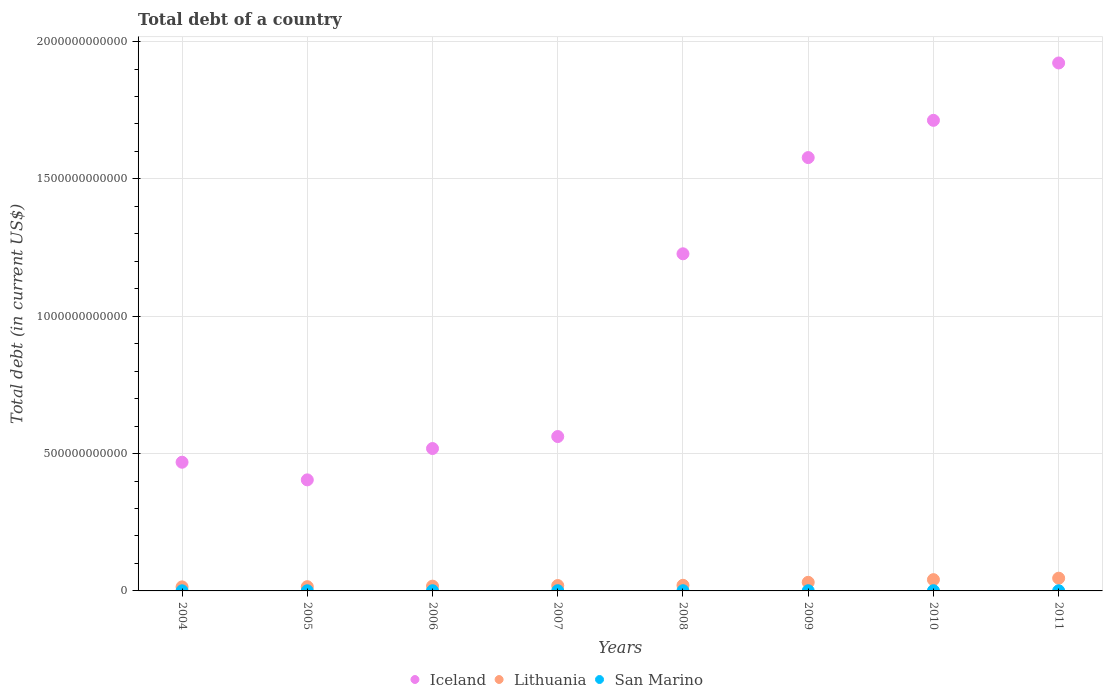Is the number of dotlines equal to the number of legend labels?
Provide a succinct answer. Yes. What is the debt in Lithuania in 2006?
Your response must be concise. 1.74e+1. Across all years, what is the maximum debt in Lithuania?
Give a very brief answer. 4.63e+1. Across all years, what is the minimum debt in San Marino?
Your response must be concise. 4.40e+08. In which year was the debt in Lithuania maximum?
Provide a succinct answer. 2011. In which year was the debt in Iceland minimum?
Keep it short and to the point. 2005. What is the total debt in San Marino in the graph?
Make the answer very short. 5.31e+09. What is the difference between the debt in Iceland in 2004 and that in 2006?
Provide a short and direct response. -4.99e+1. What is the difference between the debt in Iceland in 2010 and the debt in Lithuania in 2009?
Offer a very short reply. 1.68e+12. What is the average debt in Iceland per year?
Offer a terse response. 1.05e+12. In the year 2010, what is the difference between the debt in San Marino and debt in Lithuania?
Make the answer very short. -4.02e+1. What is the ratio of the debt in Iceland in 2008 to that in 2011?
Offer a terse response. 0.64. What is the difference between the highest and the second highest debt in San Marino?
Your answer should be very brief. 1.42e+07. What is the difference between the highest and the lowest debt in San Marino?
Make the answer very short. 3.40e+08. Is the sum of the debt in San Marino in 2005 and 2011 greater than the maximum debt in Lithuania across all years?
Your answer should be compact. No. Does the debt in San Marino monotonically increase over the years?
Your answer should be compact. No. How many dotlines are there?
Keep it short and to the point. 3. How many years are there in the graph?
Provide a succinct answer. 8. What is the difference between two consecutive major ticks on the Y-axis?
Your response must be concise. 5.00e+11. Are the values on the major ticks of Y-axis written in scientific E-notation?
Provide a succinct answer. No. Does the graph contain grids?
Make the answer very short. Yes. What is the title of the graph?
Make the answer very short. Total debt of a country. Does "European Union" appear as one of the legend labels in the graph?
Offer a very short reply. No. What is the label or title of the Y-axis?
Your response must be concise. Total debt (in current US$). What is the Total debt (in current US$) in Iceland in 2004?
Ensure brevity in your answer.  4.69e+11. What is the Total debt (in current US$) of Lithuania in 2004?
Make the answer very short. 1.47e+1. What is the Total debt (in current US$) in San Marino in 2004?
Keep it short and to the point. 4.40e+08. What is the Total debt (in current US$) of Iceland in 2005?
Offer a very short reply. 4.04e+11. What is the Total debt (in current US$) in Lithuania in 2005?
Make the answer very short. 1.54e+1. What is the Total debt (in current US$) of San Marino in 2005?
Your answer should be very brief. 5.65e+08. What is the Total debt (in current US$) in Iceland in 2006?
Your answer should be very brief. 5.18e+11. What is the Total debt (in current US$) in Lithuania in 2006?
Keep it short and to the point. 1.74e+1. What is the Total debt (in current US$) of San Marino in 2006?
Your answer should be very brief. 7.27e+08. What is the Total debt (in current US$) in Iceland in 2007?
Make the answer very short. 5.62e+11. What is the Total debt (in current US$) in Lithuania in 2007?
Give a very brief answer. 1.96e+1. What is the Total debt (in current US$) in San Marino in 2007?
Keep it short and to the point. 7.58e+08. What is the Total debt (in current US$) of Iceland in 2008?
Offer a very short reply. 1.23e+12. What is the Total debt (in current US$) in Lithuania in 2008?
Your answer should be compact. 2.05e+1. What is the Total debt (in current US$) in San Marino in 2008?
Offer a terse response. 7.66e+08. What is the Total debt (in current US$) in Iceland in 2009?
Offer a very short reply. 1.58e+12. What is the Total debt (in current US$) in Lithuania in 2009?
Offer a terse response. 3.13e+1. What is the Total debt (in current US$) in San Marino in 2009?
Your response must be concise. 6.90e+08. What is the Total debt (in current US$) of Iceland in 2010?
Ensure brevity in your answer.  1.71e+12. What is the Total debt (in current US$) in Lithuania in 2010?
Make the answer very short. 4.10e+1. What is the Total debt (in current US$) in San Marino in 2010?
Keep it short and to the point. 7.80e+08. What is the Total debt (in current US$) in Iceland in 2011?
Offer a very short reply. 1.92e+12. What is the Total debt (in current US$) of Lithuania in 2011?
Provide a short and direct response. 4.63e+1. What is the Total debt (in current US$) of San Marino in 2011?
Offer a very short reply. 5.84e+08. Across all years, what is the maximum Total debt (in current US$) of Iceland?
Your response must be concise. 1.92e+12. Across all years, what is the maximum Total debt (in current US$) in Lithuania?
Your response must be concise. 4.63e+1. Across all years, what is the maximum Total debt (in current US$) in San Marino?
Make the answer very short. 7.80e+08. Across all years, what is the minimum Total debt (in current US$) of Iceland?
Your answer should be compact. 4.04e+11. Across all years, what is the minimum Total debt (in current US$) of Lithuania?
Ensure brevity in your answer.  1.47e+1. Across all years, what is the minimum Total debt (in current US$) in San Marino?
Your response must be concise. 4.40e+08. What is the total Total debt (in current US$) in Iceland in the graph?
Ensure brevity in your answer.  8.39e+12. What is the total Total debt (in current US$) of Lithuania in the graph?
Your answer should be compact. 2.06e+11. What is the total Total debt (in current US$) of San Marino in the graph?
Make the answer very short. 5.31e+09. What is the difference between the Total debt (in current US$) in Iceland in 2004 and that in 2005?
Your answer should be compact. 6.42e+1. What is the difference between the Total debt (in current US$) of Lithuania in 2004 and that in 2005?
Your answer should be very brief. -7.45e+08. What is the difference between the Total debt (in current US$) in San Marino in 2004 and that in 2005?
Your answer should be compact. -1.25e+08. What is the difference between the Total debt (in current US$) of Iceland in 2004 and that in 2006?
Your answer should be compact. -4.99e+1. What is the difference between the Total debt (in current US$) in Lithuania in 2004 and that in 2006?
Offer a very short reply. -2.73e+09. What is the difference between the Total debt (in current US$) of San Marino in 2004 and that in 2006?
Your answer should be compact. -2.86e+08. What is the difference between the Total debt (in current US$) of Iceland in 2004 and that in 2007?
Offer a very short reply. -9.35e+1. What is the difference between the Total debt (in current US$) in Lithuania in 2004 and that in 2007?
Keep it short and to the point. -4.96e+09. What is the difference between the Total debt (in current US$) in San Marino in 2004 and that in 2007?
Give a very brief answer. -3.18e+08. What is the difference between the Total debt (in current US$) of Iceland in 2004 and that in 2008?
Provide a succinct answer. -7.59e+11. What is the difference between the Total debt (in current US$) in Lithuania in 2004 and that in 2008?
Keep it short and to the point. -5.81e+09. What is the difference between the Total debt (in current US$) in San Marino in 2004 and that in 2008?
Offer a terse response. -3.26e+08. What is the difference between the Total debt (in current US$) in Iceland in 2004 and that in 2009?
Your answer should be very brief. -1.11e+12. What is the difference between the Total debt (in current US$) in Lithuania in 2004 and that in 2009?
Make the answer very short. -1.66e+1. What is the difference between the Total debt (in current US$) of San Marino in 2004 and that in 2009?
Provide a succinct answer. -2.50e+08. What is the difference between the Total debt (in current US$) of Iceland in 2004 and that in 2010?
Offer a very short reply. -1.24e+12. What is the difference between the Total debt (in current US$) of Lithuania in 2004 and that in 2010?
Your answer should be very brief. -2.64e+1. What is the difference between the Total debt (in current US$) in San Marino in 2004 and that in 2010?
Provide a short and direct response. -3.40e+08. What is the difference between the Total debt (in current US$) in Iceland in 2004 and that in 2011?
Provide a short and direct response. -1.45e+12. What is the difference between the Total debt (in current US$) in Lithuania in 2004 and that in 2011?
Give a very brief answer. -3.17e+1. What is the difference between the Total debt (in current US$) of San Marino in 2004 and that in 2011?
Make the answer very short. -1.44e+08. What is the difference between the Total debt (in current US$) in Iceland in 2005 and that in 2006?
Your answer should be compact. -1.14e+11. What is the difference between the Total debt (in current US$) of Lithuania in 2005 and that in 2006?
Your answer should be compact. -1.99e+09. What is the difference between the Total debt (in current US$) in San Marino in 2005 and that in 2006?
Give a very brief answer. -1.62e+08. What is the difference between the Total debt (in current US$) of Iceland in 2005 and that in 2007?
Your response must be concise. -1.58e+11. What is the difference between the Total debt (in current US$) in Lithuania in 2005 and that in 2007?
Provide a succinct answer. -4.22e+09. What is the difference between the Total debt (in current US$) in San Marino in 2005 and that in 2007?
Provide a short and direct response. -1.93e+08. What is the difference between the Total debt (in current US$) of Iceland in 2005 and that in 2008?
Offer a terse response. -8.23e+11. What is the difference between the Total debt (in current US$) in Lithuania in 2005 and that in 2008?
Your answer should be compact. -5.07e+09. What is the difference between the Total debt (in current US$) of San Marino in 2005 and that in 2008?
Provide a succinct answer. -2.01e+08. What is the difference between the Total debt (in current US$) of Iceland in 2005 and that in 2009?
Give a very brief answer. -1.17e+12. What is the difference between the Total debt (in current US$) of Lithuania in 2005 and that in 2009?
Keep it short and to the point. -1.59e+1. What is the difference between the Total debt (in current US$) in San Marino in 2005 and that in 2009?
Your answer should be very brief. -1.25e+08. What is the difference between the Total debt (in current US$) of Iceland in 2005 and that in 2010?
Give a very brief answer. -1.31e+12. What is the difference between the Total debt (in current US$) in Lithuania in 2005 and that in 2010?
Offer a very short reply. -2.56e+1. What is the difference between the Total debt (in current US$) of San Marino in 2005 and that in 2010?
Provide a succinct answer. -2.15e+08. What is the difference between the Total debt (in current US$) in Iceland in 2005 and that in 2011?
Keep it short and to the point. -1.52e+12. What is the difference between the Total debt (in current US$) of Lithuania in 2005 and that in 2011?
Your response must be concise. -3.09e+1. What is the difference between the Total debt (in current US$) in San Marino in 2005 and that in 2011?
Provide a succinct answer. -1.92e+07. What is the difference between the Total debt (in current US$) in Iceland in 2006 and that in 2007?
Provide a short and direct response. -4.37e+1. What is the difference between the Total debt (in current US$) of Lithuania in 2006 and that in 2007?
Ensure brevity in your answer.  -2.23e+09. What is the difference between the Total debt (in current US$) of San Marino in 2006 and that in 2007?
Your answer should be compact. -3.13e+07. What is the difference between the Total debt (in current US$) in Iceland in 2006 and that in 2008?
Your answer should be compact. -7.09e+11. What is the difference between the Total debt (in current US$) of Lithuania in 2006 and that in 2008?
Your response must be concise. -3.08e+09. What is the difference between the Total debt (in current US$) in San Marino in 2006 and that in 2008?
Give a very brief answer. -3.93e+07. What is the difference between the Total debt (in current US$) of Iceland in 2006 and that in 2009?
Give a very brief answer. -1.06e+12. What is the difference between the Total debt (in current US$) in Lithuania in 2006 and that in 2009?
Give a very brief answer. -1.39e+1. What is the difference between the Total debt (in current US$) in San Marino in 2006 and that in 2009?
Your response must be concise. 3.67e+07. What is the difference between the Total debt (in current US$) of Iceland in 2006 and that in 2010?
Your response must be concise. -1.19e+12. What is the difference between the Total debt (in current US$) in Lithuania in 2006 and that in 2010?
Your response must be concise. -2.36e+1. What is the difference between the Total debt (in current US$) in San Marino in 2006 and that in 2010?
Your answer should be compact. -5.35e+07. What is the difference between the Total debt (in current US$) in Iceland in 2006 and that in 2011?
Ensure brevity in your answer.  -1.40e+12. What is the difference between the Total debt (in current US$) in Lithuania in 2006 and that in 2011?
Ensure brevity in your answer.  -2.89e+1. What is the difference between the Total debt (in current US$) in San Marino in 2006 and that in 2011?
Provide a short and direct response. 1.42e+08. What is the difference between the Total debt (in current US$) in Iceland in 2007 and that in 2008?
Make the answer very short. -6.65e+11. What is the difference between the Total debt (in current US$) of Lithuania in 2007 and that in 2008?
Ensure brevity in your answer.  -8.50e+08. What is the difference between the Total debt (in current US$) of San Marino in 2007 and that in 2008?
Offer a terse response. -8.04e+06. What is the difference between the Total debt (in current US$) in Iceland in 2007 and that in 2009?
Provide a short and direct response. -1.02e+12. What is the difference between the Total debt (in current US$) in Lithuania in 2007 and that in 2009?
Your answer should be compact. -1.17e+1. What is the difference between the Total debt (in current US$) of San Marino in 2007 and that in 2009?
Offer a terse response. 6.80e+07. What is the difference between the Total debt (in current US$) in Iceland in 2007 and that in 2010?
Your answer should be very brief. -1.15e+12. What is the difference between the Total debt (in current US$) of Lithuania in 2007 and that in 2010?
Provide a succinct answer. -2.14e+1. What is the difference between the Total debt (in current US$) in San Marino in 2007 and that in 2010?
Your answer should be compact. -2.23e+07. What is the difference between the Total debt (in current US$) in Iceland in 2007 and that in 2011?
Provide a succinct answer. -1.36e+12. What is the difference between the Total debt (in current US$) of Lithuania in 2007 and that in 2011?
Your answer should be very brief. -2.67e+1. What is the difference between the Total debt (in current US$) in San Marino in 2007 and that in 2011?
Ensure brevity in your answer.  1.74e+08. What is the difference between the Total debt (in current US$) in Iceland in 2008 and that in 2009?
Keep it short and to the point. -3.50e+11. What is the difference between the Total debt (in current US$) of Lithuania in 2008 and that in 2009?
Offer a very short reply. -1.08e+1. What is the difference between the Total debt (in current US$) of San Marino in 2008 and that in 2009?
Your response must be concise. 7.60e+07. What is the difference between the Total debt (in current US$) in Iceland in 2008 and that in 2010?
Make the answer very short. -4.86e+11. What is the difference between the Total debt (in current US$) in Lithuania in 2008 and that in 2010?
Keep it short and to the point. -2.06e+1. What is the difference between the Total debt (in current US$) in San Marino in 2008 and that in 2010?
Give a very brief answer. -1.42e+07. What is the difference between the Total debt (in current US$) in Iceland in 2008 and that in 2011?
Give a very brief answer. -6.95e+11. What is the difference between the Total debt (in current US$) of Lithuania in 2008 and that in 2011?
Your answer should be very brief. -2.58e+1. What is the difference between the Total debt (in current US$) in San Marino in 2008 and that in 2011?
Your answer should be compact. 1.82e+08. What is the difference between the Total debt (in current US$) in Iceland in 2009 and that in 2010?
Give a very brief answer. -1.36e+11. What is the difference between the Total debt (in current US$) of Lithuania in 2009 and that in 2010?
Your response must be concise. -9.73e+09. What is the difference between the Total debt (in current US$) in San Marino in 2009 and that in 2010?
Ensure brevity in your answer.  -9.03e+07. What is the difference between the Total debt (in current US$) of Iceland in 2009 and that in 2011?
Provide a short and direct response. -3.44e+11. What is the difference between the Total debt (in current US$) in Lithuania in 2009 and that in 2011?
Offer a very short reply. -1.50e+1. What is the difference between the Total debt (in current US$) in San Marino in 2009 and that in 2011?
Offer a very short reply. 1.06e+08. What is the difference between the Total debt (in current US$) of Iceland in 2010 and that in 2011?
Give a very brief answer. -2.09e+11. What is the difference between the Total debt (in current US$) of Lithuania in 2010 and that in 2011?
Keep it short and to the point. -5.29e+09. What is the difference between the Total debt (in current US$) of San Marino in 2010 and that in 2011?
Provide a short and direct response. 1.96e+08. What is the difference between the Total debt (in current US$) in Iceland in 2004 and the Total debt (in current US$) in Lithuania in 2005?
Offer a very short reply. 4.53e+11. What is the difference between the Total debt (in current US$) in Iceland in 2004 and the Total debt (in current US$) in San Marino in 2005?
Your response must be concise. 4.68e+11. What is the difference between the Total debt (in current US$) in Lithuania in 2004 and the Total debt (in current US$) in San Marino in 2005?
Make the answer very short. 1.41e+1. What is the difference between the Total debt (in current US$) in Iceland in 2004 and the Total debt (in current US$) in Lithuania in 2006?
Your answer should be very brief. 4.51e+11. What is the difference between the Total debt (in current US$) in Iceland in 2004 and the Total debt (in current US$) in San Marino in 2006?
Offer a very short reply. 4.68e+11. What is the difference between the Total debt (in current US$) in Lithuania in 2004 and the Total debt (in current US$) in San Marino in 2006?
Your answer should be very brief. 1.39e+1. What is the difference between the Total debt (in current US$) in Iceland in 2004 and the Total debt (in current US$) in Lithuania in 2007?
Your answer should be compact. 4.49e+11. What is the difference between the Total debt (in current US$) in Iceland in 2004 and the Total debt (in current US$) in San Marino in 2007?
Keep it short and to the point. 4.68e+11. What is the difference between the Total debt (in current US$) of Lithuania in 2004 and the Total debt (in current US$) of San Marino in 2007?
Give a very brief answer. 1.39e+1. What is the difference between the Total debt (in current US$) in Iceland in 2004 and the Total debt (in current US$) in Lithuania in 2008?
Give a very brief answer. 4.48e+11. What is the difference between the Total debt (in current US$) in Iceland in 2004 and the Total debt (in current US$) in San Marino in 2008?
Provide a short and direct response. 4.68e+11. What is the difference between the Total debt (in current US$) of Lithuania in 2004 and the Total debt (in current US$) of San Marino in 2008?
Give a very brief answer. 1.39e+1. What is the difference between the Total debt (in current US$) of Iceland in 2004 and the Total debt (in current US$) of Lithuania in 2009?
Offer a terse response. 4.37e+11. What is the difference between the Total debt (in current US$) of Iceland in 2004 and the Total debt (in current US$) of San Marino in 2009?
Your answer should be very brief. 4.68e+11. What is the difference between the Total debt (in current US$) of Lithuania in 2004 and the Total debt (in current US$) of San Marino in 2009?
Keep it short and to the point. 1.40e+1. What is the difference between the Total debt (in current US$) in Iceland in 2004 and the Total debt (in current US$) in Lithuania in 2010?
Your response must be concise. 4.27e+11. What is the difference between the Total debt (in current US$) of Iceland in 2004 and the Total debt (in current US$) of San Marino in 2010?
Provide a succinct answer. 4.68e+11. What is the difference between the Total debt (in current US$) in Lithuania in 2004 and the Total debt (in current US$) in San Marino in 2010?
Make the answer very short. 1.39e+1. What is the difference between the Total debt (in current US$) of Iceland in 2004 and the Total debt (in current US$) of Lithuania in 2011?
Provide a succinct answer. 4.22e+11. What is the difference between the Total debt (in current US$) of Iceland in 2004 and the Total debt (in current US$) of San Marino in 2011?
Your answer should be very brief. 4.68e+11. What is the difference between the Total debt (in current US$) of Lithuania in 2004 and the Total debt (in current US$) of San Marino in 2011?
Offer a terse response. 1.41e+1. What is the difference between the Total debt (in current US$) of Iceland in 2005 and the Total debt (in current US$) of Lithuania in 2006?
Your answer should be compact. 3.87e+11. What is the difference between the Total debt (in current US$) in Iceland in 2005 and the Total debt (in current US$) in San Marino in 2006?
Ensure brevity in your answer.  4.04e+11. What is the difference between the Total debt (in current US$) of Lithuania in 2005 and the Total debt (in current US$) of San Marino in 2006?
Ensure brevity in your answer.  1.47e+1. What is the difference between the Total debt (in current US$) of Iceland in 2005 and the Total debt (in current US$) of Lithuania in 2007?
Ensure brevity in your answer.  3.85e+11. What is the difference between the Total debt (in current US$) of Iceland in 2005 and the Total debt (in current US$) of San Marino in 2007?
Your answer should be compact. 4.04e+11. What is the difference between the Total debt (in current US$) of Lithuania in 2005 and the Total debt (in current US$) of San Marino in 2007?
Your answer should be very brief. 1.46e+1. What is the difference between the Total debt (in current US$) in Iceland in 2005 and the Total debt (in current US$) in Lithuania in 2008?
Give a very brief answer. 3.84e+11. What is the difference between the Total debt (in current US$) of Iceland in 2005 and the Total debt (in current US$) of San Marino in 2008?
Offer a terse response. 4.04e+11. What is the difference between the Total debt (in current US$) in Lithuania in 2005 and the Total debt (in current US$) in San Marino in 2008?
Offer a terse response. 1.46e+1. What is the difference between the Total debt (in current US$) of Iceland in 2005 and the Total debt (in current US$) of Lithuania in 2009?
Keep it short and to the point. 3.73e+11. What is the difference between the Total debt (in current US$) of Iceland in 2005 and the Total debt (in current US$) of San Marino in 2009?
Your answer should be compact. 4.04e+11. What is the difference between the Total debt (in current US$) in Lithuania in 2005 and the Total debt (in current US$) in San Marino in 2009?
Give a very brief answer. 1.47e+1. What is the difference between the Total debt (in current US$) in Iceland in 2005 and the Total debt (in current US$) in Lithuania in 2010?
Keep it short and to the point. 3.63e+11. What is the difference between the Total debt (in current US$) of Iceland in 2005 and the Total debt (in current US$) of San Marino in 2010?
Your response must be concise. 4.04e+11. What is the difference between the Total debt (in current US$) of Lithuania in 2005 and the Total debt (in current US$) of San Marino in 2010?
Your answer should be very brief. 1.46e+1. What is the difference between the Total debt (in current US$) in Iceland in 2005 and the Total debt (in current US$) in Lithuania in 2011?
Ensure brevity in your answer.  3.58e+11. What is the difference between the Total debt (in current US$) of Iceland in 2005 and the Total debt (in current US$) of San Marino in 2011?
Provide a succinct answer. 4.04e+11. What is the difference between the Total debt (in current US$) of Lithuania in 2005 and the Total debt (in current US$) of San Marino in 2011?
Give a very brief answer. 1.48e+1. What is the difference between the Total debt (in current US$) in Iceland in 2006 and the Total debt (in current US$) in Lithuania in 2007?
Make the answer very short. 4.99e+11. What is the difference between the Total debt (in current US$) of Iceland in 2006 and the Total debt (in current US$) of San Marino in 2007?
Provide a succinct answer. 5.18e+11. What is the difference between the Total debt (in current US$) in Lithuania in 2006 and the Total debt (in current US$) in San Marino in 2007?
Make the answer very short. 1.66e+1. What is the difference between the Total debt (in current US$) of Iceland in 2006 and the Total debt (in current US$) of Lithuania in 2008?
Offer a very short reply. 4.98e+11. What is the difference between the Total debt (in current US$) in Iceland in 2006 and the Total debt (in current US$) in San Marino in 2008?
Ensure brevity in your answer.  5.18e+11. What is the difference between the Total debt (in current US$) of Lithuania in 2006 and the Total debt (in current US$) of San Marino in 2008?
Your response must be concise. 1.66e+1. What is the difference between the Total debt (in current US$) in Iceland in 2006 and the Total debt (in current US$) in Lithuania in 2009?
Offer a very short reply. 4.87e+11. What is the difference between the Total debt (in current US$) in Iceland in 2006 and the Total debt (in current US$) in San Marino in 2009?
Give a very brief answer. 5.18e+11. What is the difference between the Total debt (in current US$) of Lithuania in 2006 and the Total debt (in current US$) of San Marino in 2009?
Ensure brevity in your answer.  1.67e+1. What is the difference between the Total debt (in current US$) in Iceland in 2006 and the Total debt (in current US$) in Lithuania in 2010?
Your answer should be very brief. 4.77e+11. What is the difference between the Total debt (in current US$) of Iceland in 2006 and the Total debt (in current US$) of San Marino in 2010?
Offer a terse response. 5.18e+11. What is the difference between the Total debt (in current US$) of Lithuania in 2006 and the Total debt (in current US$) of San Marino in 2010?
Provide a short and direct response. 1.66e+1. What is the difference between the Total debt (in current US$) of Iceland in 2006 and the Total debt (in current US$) of Lithuania in 2011?
Offer a very short reply. 4.72e+11. What is the difference between the Total debt (in current US$) in Iceland in 2006 and the Total debt (in current US$) in San Marino in 2011?
Provide a short and direct response. 5.18e+11. What is the difference between the Total debt (in current US$) in Lithuania in 2006 and the Total debt (in current US$) in San Marino in 2011?
Offer a very short reply. 1.68e+1. What is the difference between the Total debt (in current US$) in Iceland in 2007 and the Total debt (in current US$) in Lithuania in 2008?
Provide a succinct answer. 5.42e+11. What is the difference between the Total debt (in current US$) of Iceland in 2007 and the Total debt (in current US$) of San Marino in 2008?
Offer a terse response. 5.61e+11. What is the difference between the Total debt (in current US$) of Lithuania in 2007 and the Total debt (in current US$) of San Marino in 2008?
Keep it short and to the point. 1.88e+1. What is the difference between the Total debt (in current US$) in Iceland in 2007 and the Total debt (in current US$) in Lithuania in 2009?
Give a very brief answer. 5.31e+11. What is the difference between the Total debt (in current US$) of Iceland in 2007 and the Total debt (in current US$) of San Marino in 2009?
Keep it short and to the point. 5.61e+11. What is the difference between the Total debt (in current US$) in Lithuania in 2007 and the Total debt (in current US$) in San Marino in 2009?
Offer a very short reply. 1.89e+1. What is the difference between the Total debt (in current US$) in Iceland in 2007 and the Total debt (in current US$) in Lithuania in 2010?
Give a very brief answer. 5.21e+11. What is the difference between the Total debt (in current US$) of Iceland in 2007 and the Total debt (in current US$) of San Marino in 2010?
Make the answer very short. 5.61e+11. What is the difference between the Total debt (in current US$) in Lithuania in 2007 and the Total debt (in current US$) in San Marino in 2010?
Provide a succinct answer. 1.88e+1. What is the difference between the Total debt (in current US$) in Iceland in 2007 and the Total debt (in current US$) in Lithuania in 2011?
Make the answer very short. 5.16e+11. What is the difference between the Total debt (in current US$) of Iceland in 2007 and the Total debt (in current US$) of San Marino in 2011?
Offer a terse response. 5.61e+11. What is the difference between the Total debt (in current US$) in Lithuania in 2007 and the Total debt (in current US$) in San Marino in 2011?
Make the answer very short. 1.90e+1. What is the difference between the Total debt (in current US$) of Iceland in 2008 and the Total debt (in current US$) of Lithuania in 2009?
Provide a succinct answer. 1.20e+12. What is the difference between the Total debt (in current US$) in Iceland in 2008 and the Total debt (in current US$) in San Marino in 2009?
Your answer should be very brief. 1.23e+12. What is the difference between the Total debt (in current US$) in Lithuania in 2008 and the Total debt (in current US$) in San Marino in 2009?
Keep it short and to the point. 1.98e+1. What is the difference between the Total debt (in current US$) of Iceland in 2008 and the Total debt (in current US$) of Lithuania in 2010?
Your answer should be very brief. 1.19e+12. What is the difference between the Total debt (in current US$) in Iceland in 2008 and the Total debt (in current US$) in San Marino in 2010?
Offer a terse response. 1.23e+12. What is the difference between the Total debt (in current US$) in Lithuania in 2008 and the Total debt (in current US$) in San Marino in 2010?
Provide a short and direct response. 1.97e+1. What is the difference between the Total debt (in current US$) of Iceland in 2008 and the Total debt (in current US$) of Lithuania in 2011?
Ensure brevity in your answer.  1.18e+12. What is the difference between the Total debt (in current US$) of Iceland in 2008 and the Total debt (in current US$) of San Marino in 2011?
Keep it short and to the point. 1.23e+12. What is the difference between the Total debt (in current US$) in Lithuania in 2008 and the Total debt (in current US$) in San Marino in 2011?
Ensure brevity in your answer.  1.99e+1. What is the difference between the Total debt (in current US$) in Iceland in 2009 and the Total debt (in current US$) in Lithuania in 2010?
Your answer should be very brief. 1.54e+12. What is the difference between the Total debt (in current US$) in Iceland in 2009 and the Total debt (in current US$) in San Marino in 2010?
Your answer should be very brief. 1.58e+12. What is the difference between the Total debt (in current US$) in Lithuania in 2009 and the Total debt (in current US$) in San Marino in 2010?
Ensure brevity in your answer.  3.05e+1. What is the difference between the Total debt (in current US$) in Iceland in 2009 and the Total debt (in current US$) in Lithuania in 2011?
Provide a succinct answer. 1.53e+12. What is the difference between the Total debt (in current US$) in Iceland in 2009 and the Total debt (in current US$) in San Marino in 2011?
Offer a very short reply. 1.58e+12. What is the difference between the Total debt (in current US$) in Lithuania in 2009 and the Total debt (in current US$) in San Marino in 2011?
Keep it short and to the point. 3.07e+1. What is the difference between the Total debt (in current US$) of Iceland in 2010 and the Total debt (in current US$) of Lithuania in 2011?
Make the answer very short. 1.67e+12. What is the difference between the Total debt (in current US$) in Iceland in 2010 and the Total debt (in current US$) in San Marino in 2011?
Offer a very short reply. 1.71e+12. What is the difference between the Total debt (in current US$) of Lithuania in 2010 and the Total debt (in current US$) of San Marino in 2011?
Your answer should be compact. 4.04e+1. What is the average Total debt (in current US$) in Iceland per year?
Offer a very short reply. 1.05e+12. What is the average Total debt (in current US$) of Lithuania per year?
Keep it short and to the point. 2.58e+1. What is the average Total debt (in current US$) in San Marino per year?
Provide a succinct answer. 6.64e+08. In the year 2004, what is the difference between the Total debt (in current US$) of Iceland and Total debt (in current US$) of Lithuania?
Offer a very short reply. 4.54e+11. In the year 2004, what is the difference between the Total debt (in current US$) of Iceland and Total debt (in current US$) of San Marino?
Make the answer very short. 4.68e+11. In the year 2004, what is the difference between the Total debt (in current US$) of Lithuania and Total debt (in current US$) of San Marino?
Your answer should be compact. 1.42e+1. In the year 2005, what is the difference between the Total debt (in current US$) of Iceland and Total debt (in current US$) of Lithuania?
Offer a terse response. 3.89e+11. In the year 2005, what is the difference between the Total debt (in current US$) in Iceland and Total debt (in current US$) in San Marino?
Provide a short and direct response. 4.04e+11. In the year 2005, what is the difference between the Total debt (in current US$) of Lithuania and Total debt (in current US$) of San Marino?
Provide a short and direct response. 1.48e+1. In the year 2006, what is the difference between the Total debt (in current US$) in Iceland and Total debt (in current US$) in Lithuania?
Provide a succinct answer. 5.01e+11. In the year 2006, what is the difference between the Total debt (in current US$) of Iceland and Total debt (in current US$) of San Marino?
Your answer should be very brief. 5.18e+11. In the year 2006, what is the difference between the Total debt (in current US$) of Lithuania and Total debt (in current US$) of San Marino?
Your answer should be compact. 1.67e+1. In the year 2007, what is the difference between the Total debt (in current US$) of Iceland and Total debt (in current US$) of Lithuania?
Provide a succinct answer. 5.42e+11. In the year 2007, what is the difference between the Total debt (in current US$) of Iceland and Total debt (in current US$) of San Marino?
Offer a very short reply. 5.61e+11. In the year 2007, what is the difference between the Total debt (in current US$) of Lithuania and Total debt (in current US$) of San Marino?
Your answer should be very brief. 1.89e+1. In the year 2008, what is the difference between the Total debt (in current US$) in Iceland and Total debt (in current US$) in Lithuania?
Offer a very short reply. 1.21e+12. In the year 2008, what is the difference between the Total debt (in current US$) in Iceland and Total debt (in current US$) in San Marino?
Keep it short and to the point. 1.23e+12. In the year 2008, what is the difference between the Total debt (in current US$) in Lithuania and Total debt (in current US$) in San Marino?
Give a very brief answer. 1.97e+1. In the year 2009, what is the difference between the Total debt (in current US$) of Iceland and Total debt (in current US$) of Lithuania?
Offer a terse response. 1.55e+12. In the year 2009, what is the difference between the Total debt (in current US$) of Iceland and Total debt (in current US$) of San Marino?
Make the answer very short. 1.58e+12. In the year 2009, what is the difference between the Total debt (in current US$) in Lithuania and Total debt (in current US$) in San Marino?
Provide a short and direct response. 3.06e+1. In the year 2010, what is the difference between the Total debt (in current US$) in Iceland and Total debt (in current US$) in Lithuania?
Your answer should be very brief. 1.67e+12. In the year 2010, what is the difference between the Total debt (in current US$) of Iceland and Total debt (in current US$) of San Marino?
Your answer should be compact. 1.71e+12. In the year 2010, what is the difference between the Total debt (in current US$) of Lithuania and Total debt (in current US$) of San Marino?
Your response must be concise. 4.02e+1. In the year 2011, what is the difference between the Total debt (in current US$) of Iceland and Total debt (in current US$) of Lithuania?
Keep it short and to the point. 1.88e+12. In the year 2011, what is the difference between the Total debt (in current US$) of Iceland and Total debt (in current US$) of San Marino?
Your response must be concise. 1.92e+12. In the year 2011, what is the difference between the Total debt (in current US$) of Lithuania and Total debt (in current US$) of San Marino?
Keep it short and to the point. 4.57e+1. What is the ratio of the Total debt (in current US$) of Iceland in 2004 to that in 2005?
Your answer should be compact. 1.16. What is the ratio of the Total debt (in current US$) in Lithuania in 2004 to that in 2005?
Ensure brevity in your answer.  0.95. What is the ratio of the Total debt (in current US$) of San Marino in 2004 to that in 2005?
Keep it short and to the point. 0.78. What is the ratio of the Total debt (in current US$) in Iceland in 2004 to that in 2006?
Your answer should be very brief. 0.9. What is the ratio of the Total debt (in current US$) in Lithuania in 2004 to that in 2006?
Your answer should be compact. 0.84. What is the ratio of the Total debt (in current US$) in San Marino in 2004 to that in 2006?
Your answer should be compact. 0.61. What is the ratio of the Total debt (in current US$) in Iceland in 2004 to that in 2007?
Your answer should be compact. 0.83. What is the ratio of the Total debt (in current US$) of Lithuania in 2004 to that in 2007?
Your answer should be very brief. 0.75. What is the ratio of the Total debt (in current US$) of San Marino in 2004 to that in 2007?
Offer a very short reply. 0.58. What is the ratio of the Total debt (in current US$) of Iceland in 2004 to that in 2008?
Your answer should be compact. 0.38. What is the ratio of the Total debt (in current US$) in Lithuania in 2004 to that in 2008?
Make the answer very short. 0.72. What is the ratio of the Total debt (in current US$) of San Marino in 2004 to that in 2008?
Give a very brief answer. 0.57. What is the ratio of the Total debt (in current US$) of Iceland in 2004 to that in 2009?
Offer a very short reply. 0.3. What is the ratio of the Total debt (in current US$) in Lithuania in 2004 to that in 2009?
Give a very brief answer. 0.47. What is the ratio of the Total debt (in current US$) in San Marino in 2004 to that in 2009?
Your answer should be compact. 0.64. What is the ratio of the Total debt (in current US$) of Iceland in 2004 to that in 2010?
Offer a very short reply. 0.27. What is the ratio of the Total debt (in current US$) of Lithuania in 2004 to that in 2010?
Provide a short and direct response. 0.36. What is the ratio of the Total debt (in current US$) of San Marino in 2004 to that in 2010?
Your response must be concise. 0.56. What is the ratio of the Total debt (in current US$) in Iceland in 2004 to that in 2011?
Make the answer very short. 0.24. What is the ratio of the Total debt (in current US$) of Lithuania in 2004 to that in 2011?
Offer a terse response. 0.32. What is the ratio of the Total debt (in current US$) in San Marino in 2004 to that in 2011?
Offer a terse response. 0.75. What is the ratio of the Total debt (in current US$) of Iceland in 2005 to that in 2006?
Give a very brief answer. 0.78. What is the ratio of the Total debt (in current US$) in Lithuania in 2005 to that in 2006?
Keep it short and to the point. 0.89. What is the ratio of the Total debt (in current US$) in San Marino in 2005 to that in 2006?
Ensure brevity in your answer.  0.78. What is the ratio of the Total debt (in current US$) in Iceland in 2005 to that in 2007?
Provide a short and direct response. 0.72. What is the ratio of the Total debt (in current US$) in Lithuania in 2005 to that in 2007?
Offer a very short reply. 0.79. What is the ratio of the Total debt (in current US$) in San Marino in 2005 to that in 2007?
Give a very brief answer. 0.75. What is the ratio of the Total debt (in current US$) of Iceland in 2005 to that in 2008?
Offer a terse response. 0.33. What is the ratio of the Total debt (in current US$) in Lithuania in 2005 to that in 2008?
Your response must be concise. 0.75. What is the ratio of the Total debt (in current US$) in San Marino in 2005 to that in 2008?
Ensure brevity in your answer.  0.74. What is the ratio of the Total debt (in current US$) of Iceland in 2005 to that in 2009?
Your answer should be very brief. 0.26. What is the ratio of the Total debt (in current US$) in Lithuania in 2005 to that in 2009?
Your answer should be very brief. 0.49. What is the ratio of the Total debt (in current US$) of San Marino in 2005 to that in 2009?
Provide a short and direct response. 0.82. What is the ratio of the Total debt (in current US$) of Iceland in 2005 to that in 2010?
Give a very brief answer. 0.24. What is the ratio of the Total debt (in current US$) in Lithuania in 2005 to that in 2010?
Ensure brevity in your answer.  0.38. What is the ratio of the Total debt (in current US$) in San Marino in 2005 to that in 2010?
Give a very brief answer. 0.72. What is the ratio of the Total debt (in current US$) of Iceland in 2005 to that in 2011?
Your answer should be very brief. 0.21. What is the ratio of the Total debt (in current US$) of Lithuania in 2005 to that in 2011?
Offer a terse response. 0.33. What is the ratio of the Total debt (in current US$) of San Marino in 2005 to that in 2011?
Your answer should be very brief. 0.97. What is the ratio of the Total debt (in current US$) in Iceland in 2006 to that in 2007?
Ensure brevity in your answer.  0.92. What is the ratio of the Total debt (in current US$) in Lithuania in 2006 to that in 2007?
Keep it short and to the point. 0.89. What is the ratio of the Total debt (in current US$) in San Marino in 2006 to that in 2007?
Your answer should be very brief. 0.96. What is the ratio of the Total debt (in current US$) in Iceland in 2006 to that in 2008?
Make the answer very short. 0.42. What is the ratio of the Total debt (in current US$) in Lithuania in 2006 to that in 2008?
Provide a succinct answer. 0.85. What is the ratio of the Total debt (in current US$) in San Marino in 2006 to that in 2008?
Your response must be concise. 0.95. What is the ratio of the Total debt (in current US$) in Iceland in 2006 to that in 2009?
Make the answer very short. 0.33. What is the ratio of the Total debt (in current US$) of Lithuania in 2006 to that in 2009?
Ensure brevity in your answer.  0.56. What is the ratio of the Total debt (in current US$) of San Marino in 2006 to that in 2009?
Provide a short and direct response. 1.05. What is the ratio of the Total debt (in current US$) in Iceland in 2006 to that in 2010?
Your response must be concise. 0.3. What is the ratio of the Total debt (in current US$) of Lithuania in 2006 to that in 2010?
Your response must be concise. 0.42. What is the ratio of the Total debt (in current US$) of San Marino in 2006 to that in 2010?
Your answer should be compact. 0.93. What is the ratio of the Total debt (in current US$) of Iceland in 2006 to that in 2011?
Your answer should be compact. 0.27. What is the ratio of the Total debt (in current US$) of Lithuania in 2006 to that in 2011?
Give a very brief answer. 0.38. What is the ratio of the Total debt (in current US$) in San Marino in 2006 to that in 2011?
Your answer should be compact. 1.24. What is the ratio of the Total debt (in current US$) in Iceland in 2007 to that in 2008?
Offer a terse response. 0.46. What is the ratio of the Total debt (in current US$) of Lithuania in 2007 to that in 2008?
Your answer should be very brief. 0.96. What is the ratio of the Total debt (in current US$) in Iceland in 2007 to that in 2009?
Provide a succinct answer. 0.36. What is the ratio of the Total debt (in current US$) of Lithuania in 2007 to that in 2009?
Make the answer very short. 0.63. What is the ratio of the Total debt (in current US$) of San Marino in 2007 to that in 2009?
Give a very brief answer. 1.1. What is the ratio of the Total debt (in current US$) in Iceland in 2007 to that in 2010?
Keep it short and to the point. 0.33. What is the ratio of the Total debt (in current US$) of Lithuania in 2007 to that in 2010?
Your response must be concise. 0.48. What is the ratio of the Total debt (in current US$) of San Marino in 2007 to that in 2010?
Your answer should be very brief. 0.97. What is the ratio of the Total debt (in current US$) of Iceland in 2007 to that in 2011?
Your response must be concise. 0.29. What is the ratio of the Total debt (in current US$) of Lithuania in 2007 to that in 2011?
Provide a short and direct response. 0.42. What is the ratio of the Total debt (in current US$) of San Marino in 2007 to that in 2011?
Your answer should be compact. 1.3. What is the ratio of the Total debt (in current US$) of Iceland in 2008 to that in 2009?
Your answer should be compact. 0.78. What is the ratio of the Total debt (in current US$) in Lithuania in 2008 to that in 2009?
Your answer should be compact. 0.65. What is the ratio of the Total debt (in current US$) in San Marino in 2008 to that in 2009?
Provide a succinct answer. 1.11. What is the ratio of the Total debt (in current US$) of Iceland in 2008 to that in 2010?
Provide a short and direct response. 0.72. What is the ratio of the Total debt (in current US$) of Lithuania in 2008 to that in 2010?
Offer a terse response. 0.5. What is the ratio of the Total debt (in current US$) of San Marino in 2008 to that in 2010?
Offer a terse response. 0.98. What is the ratio of the Total debt (in current US$) in Iceland in 2008 to that in 2011?
Provide a succinct answer. 0.64. What is the ratio of the Total debt (in current US$) in Lithuania in 2008 to that in 2011?
Keep it short and to the point. 0.44. What is the ratio of the Total debt (in current US$) in San Marino in 2008 to that in 2011?
Keep it short and to the point. 1.31. What is the ratio of the Total debt (in current US$) of Iceland in 2009 to that in 2010?
Provide a succinct answer. 0.92. What is the ratio of the Total debt (in current US$) in Lithuania in 2009 to that in 2010?
Your answer should be very brief. 0.76. What is the ratio of the Total debt (in current US$) of San Marino in 2009 to that in 2010?
Give a very brief answer. 0.88. What is the ratio of the Total debt (in current US$) in Iceland in 2009 to that in 2011?
Give a very brief answer. 0.82. What is the ratio of the Total debt (in current US$) of Lithuania in 2009 to that in 2011?
Make the answer very short. 0.68. What is the ratio of the Total debt (in current US$) of San Marino in 2009 to that in 2011?
Make the answer very short. 1.18. What is the ratio of the Total debt (in current US$) of Iceland in 2010 to that in 2011?
Ensure brevity in your answer.  0.89. What is the ratio of the Total debt (in current US$) in Lithuania in 2010 to that in 2011?
Your response must be concise. 0.89. What is the ratio of the Total debt (in current US$) of San Marino in 2010 to that in 2011?
Make the answer very short. 1.34. What is the difference between the highest and the second highest Total debt (in current US$) of Iceland?
Offer a terse response. 2.09e+11. What is the difference between the highest and the second highest Total debt (in current US$) in Lithuania?
Offer a terse response. 5.29e+09. What is the difference between the highest and the second highest Total debt (in current US$) of San Marino?
Give a very brief answer. 1.42e+07. What is the difference between the highest and the lowest Total debt (in current US$) of Iceland?
Offer a very short reply. 1.52e+12. What is the difference between the highest and the lowest Total debt (in current US$) of Lithuania?
Your answer should be compact. 3.17e+1. What is the difference between the highest and the lowest Total debt (in current US$) in San Marino?
Ensure brevity in your answer.  3.40e+08. 